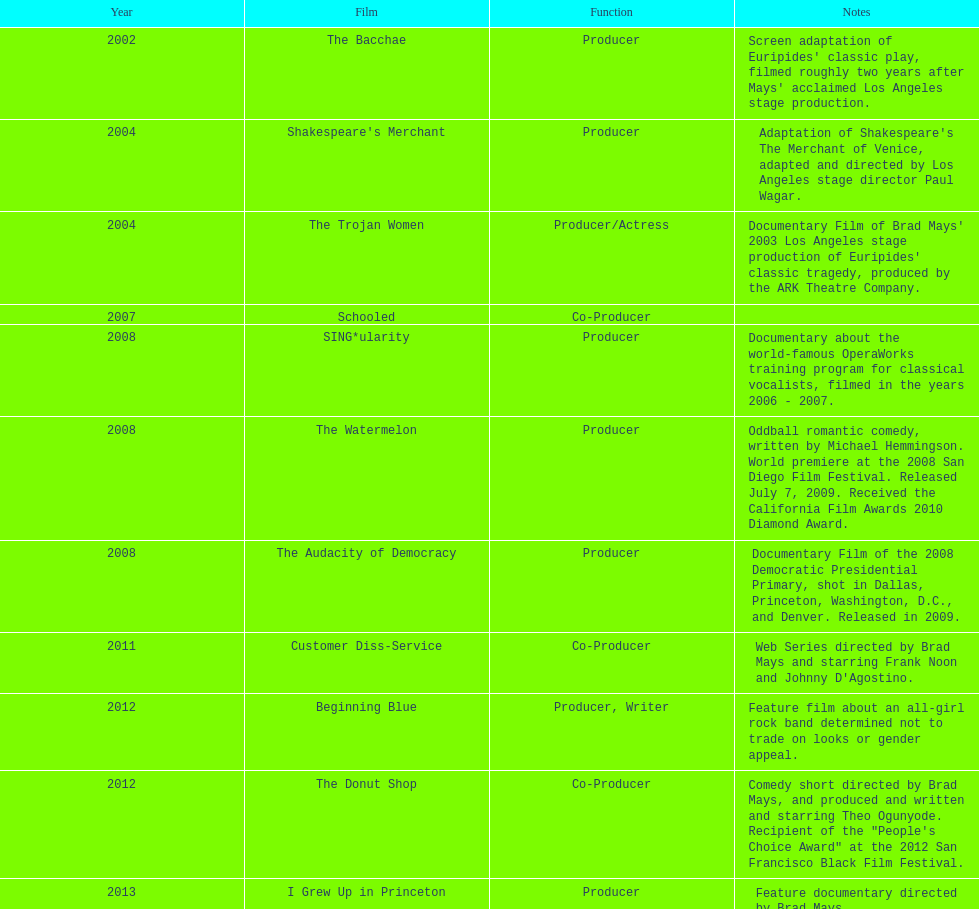Since 2010, how many films has ms. starfelt been involved in producing? 4. 